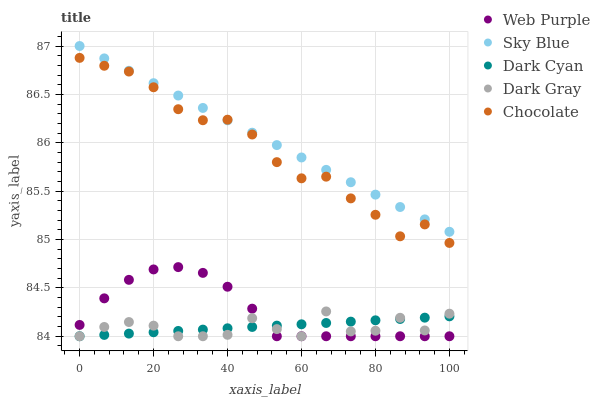Does Dark Gray have the minimum area under the curve?
Answer yes or no. Yes. Does Sky Blue have the maximum area under the curve?
Answer yes or no. Yes. Does Web Purple have the minimum area under the curve?
Answer yes or no. No. Does Web Purple have the maximum area under the curve?
Answer yes or no. No. Is Sky Blue the smoothest?
Answer yes or no. Yes. Is Dark Gray the roughest?
Answer yes or no. Yes. Is Web Purple the smoothest?
Answer yes or no. No. Is Web Purple the roughest?
Answer yes or no. No. Does Dark Cyan have the lowest value?
Answer yes or no. Yes. Does Sky Blue have the lowest value?
Answer yes or no. No. Does Sky Blue have the highest value?
Answer yes or no. Yes. Does Web Purple have the highest value?
Answer yes or no. No. Is Dark Cyan less than Chocolate?
Answer yes or no. Yes. Is Chocolate greater than Dark Cyan?
Answer yes or no. Yes. Does Dark Gray intersect Web Purple?
Answer yes or no. Yes. Is Dark Gray less than Web Purple?
Answer yes or no. No. Is Dark Gray greater than Web Purple?
Answer yes or no. No. Does Dark Cyan intersect Chocolate?
Answer yes or no. No. 